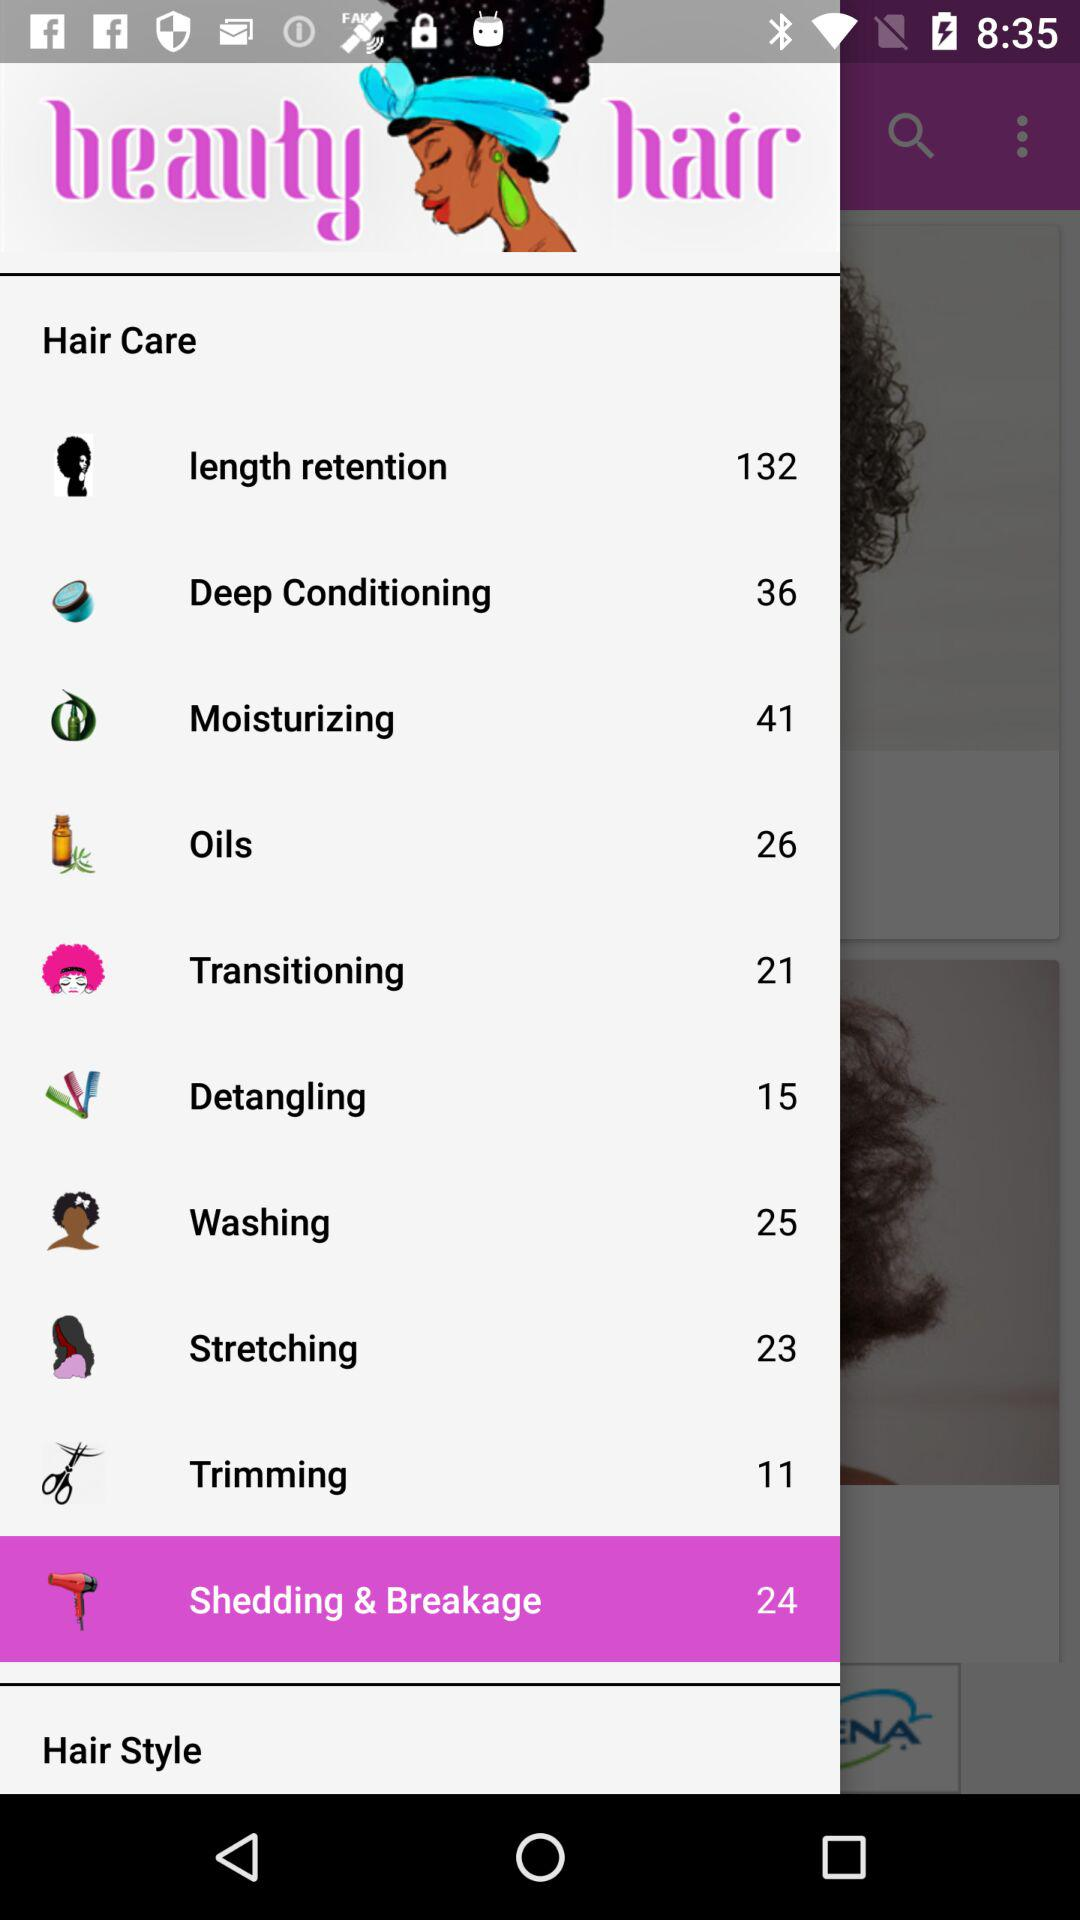How many items are there in "Washing"? There are 25 items in "Washing". 